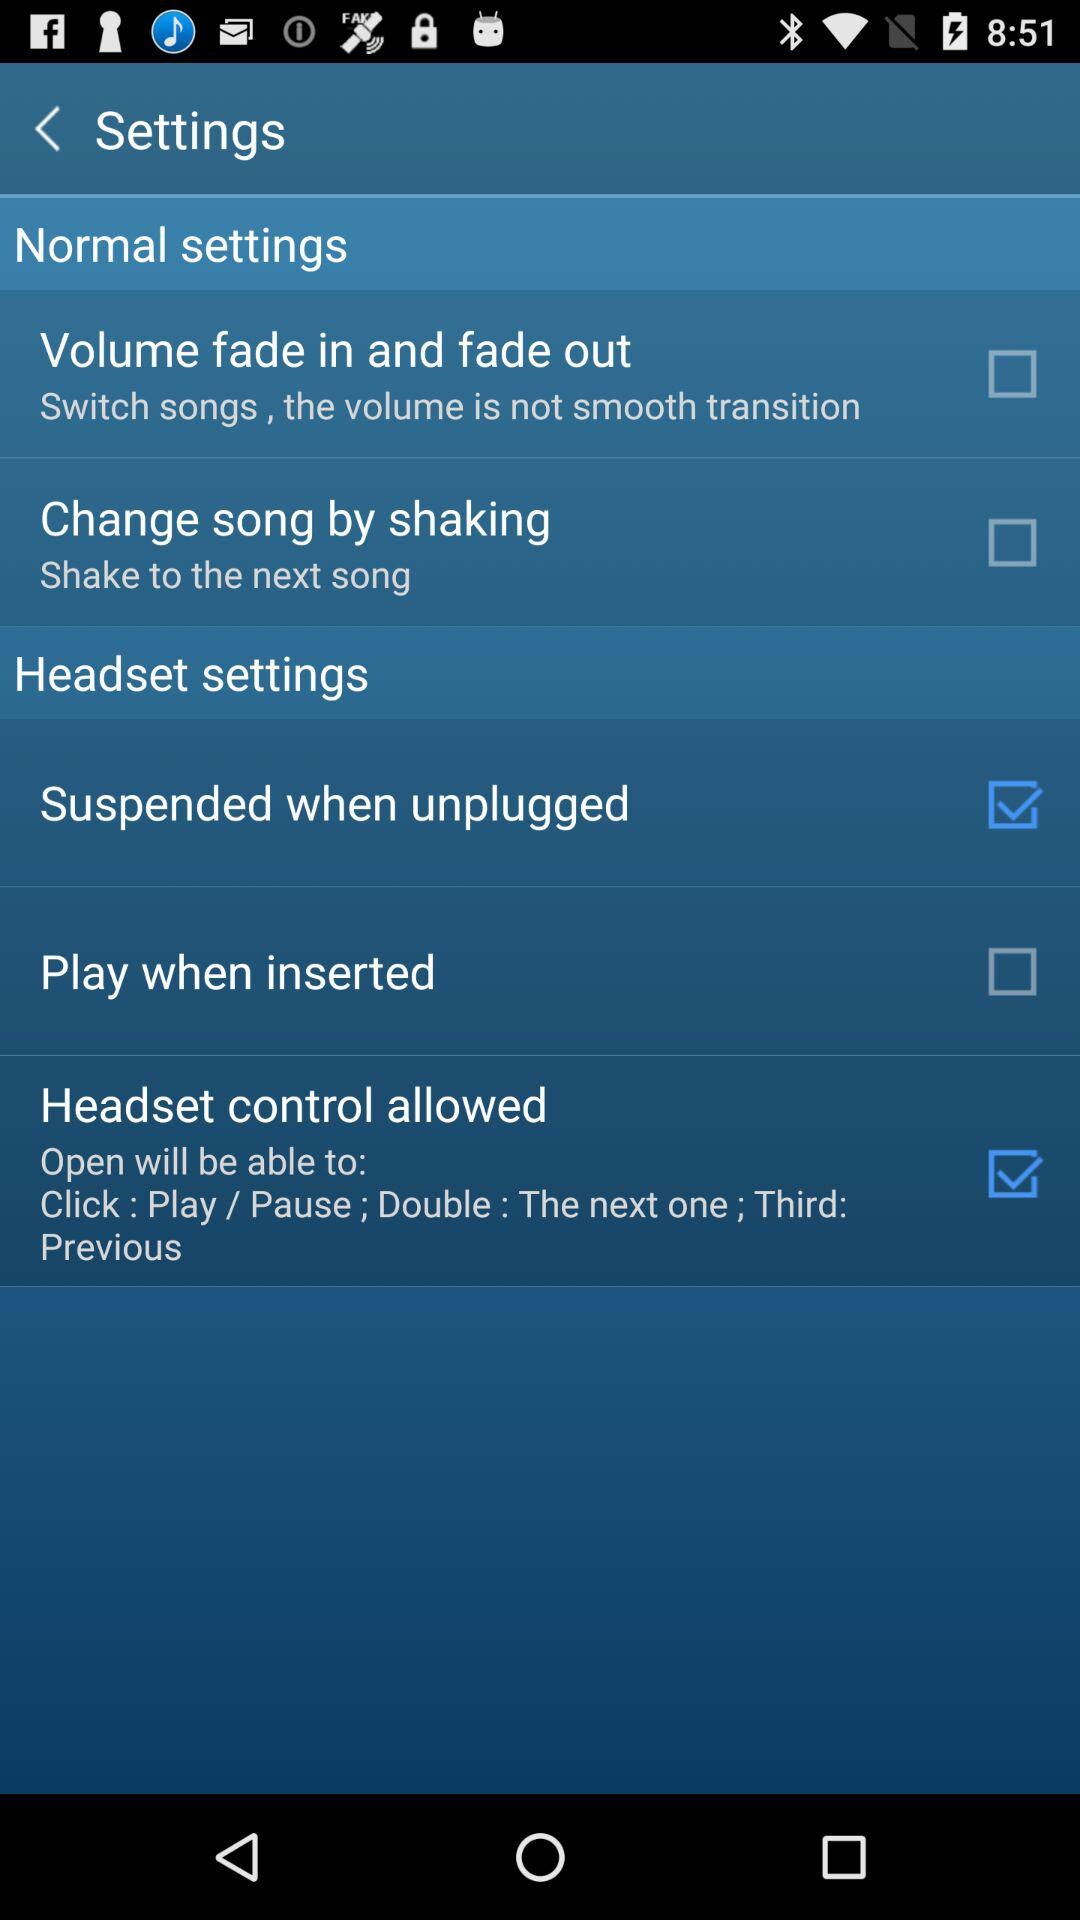What is the status of the "Suspended when unplugged"? The status is "on". 